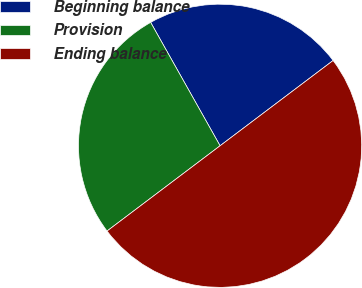Convert chart. <chart><loc_0><loc_0><loc_500><loc_500><pie_chart><fcel>Beginning balance<fcel>Provision<fcel>Ending balance<nl><fcel>22.87%<fcel>27.13%<fcel>50.0%<nl></chart> 